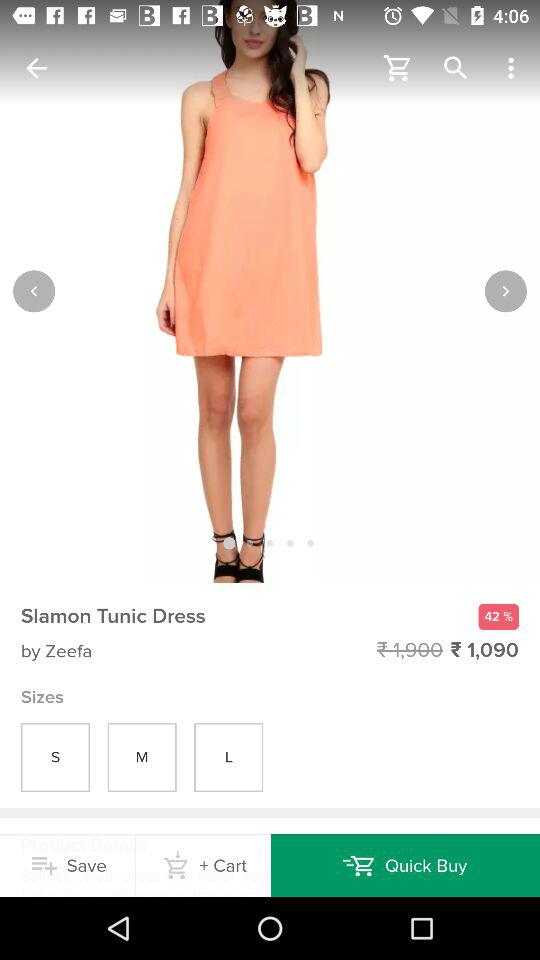How many sizes are available for this dress?
Answer the question using a single word or phrase. 3 